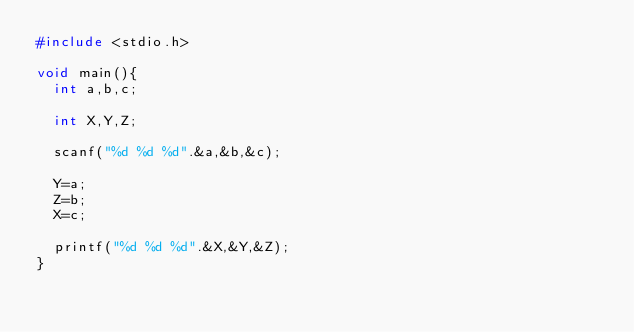Convert code to text. <code><loc_0><loc_0><loc_500><loc_500><_C_>#include <stdio.h>

void main(){
  int a,b,c;

  int X,Y,Z;
  
  scanf("%d %d %d".&a,&b,&c);

  Y=a;
  Z=b;
  X=c;

  printf("%d %d %d".&X,&Y,&Z);
}
</code> 